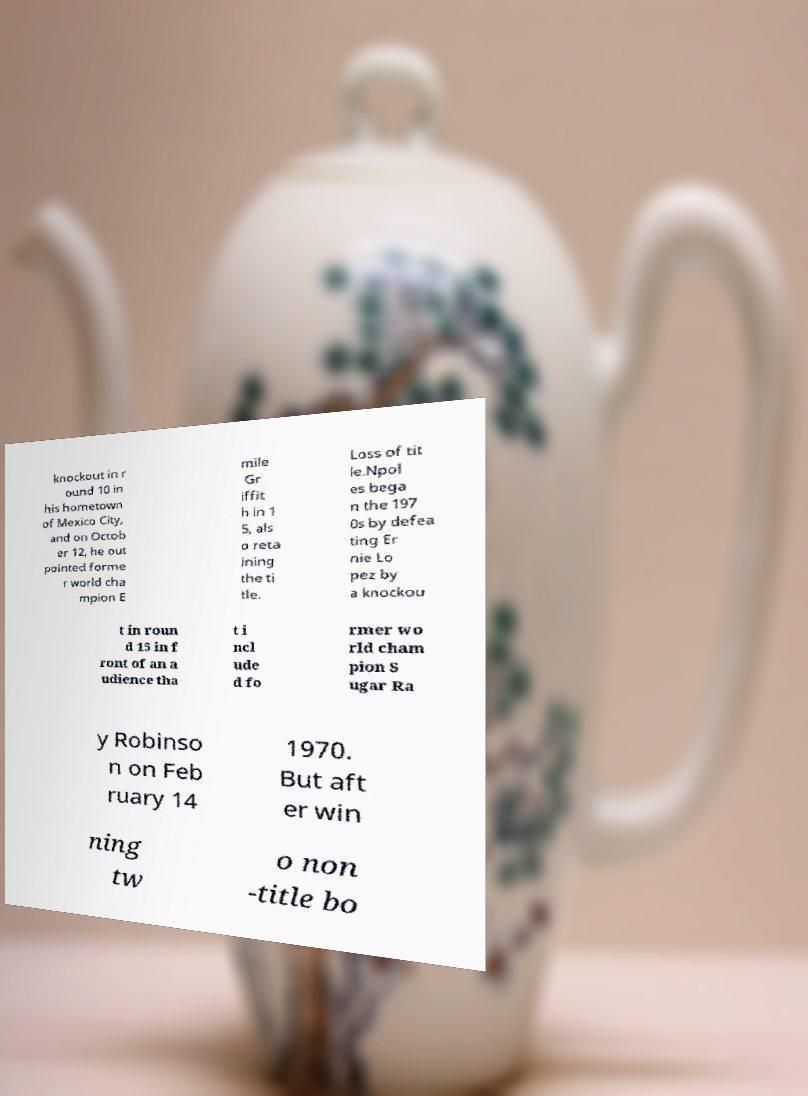Can you accurately transcribe the text from the provided image for me? knockout in r ound 10 in his hometown of Mexico City, and on Octob er 12, he out pointed forme r world cha mpion E mile Gr iffit h in 1 5, als o reta ining the ti tle. Loss of tit le.Npol es bega n the 197 0s by defea ting Er nie Lo pez by a knockou t in roun d 15 in f ront of an a udience tha t i ncl ude d fo rmer wo rld cham pion S ugar Ra y Robinso n on Feb ruary 14 1970. But aft er win ning tw o non -title bo 